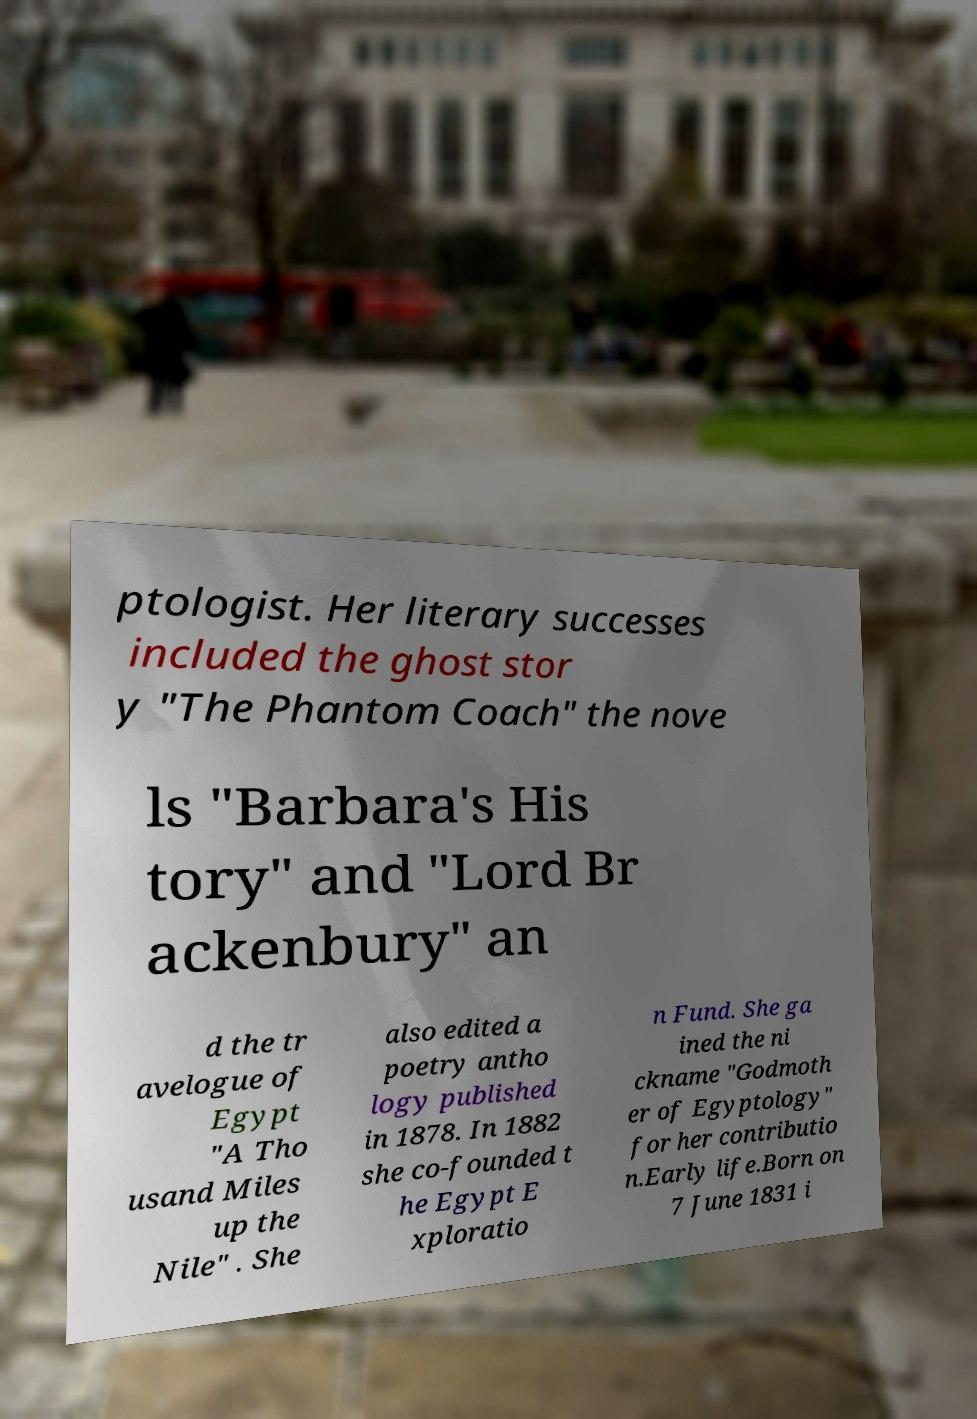Could you assist in decoding the text presented in this image and type it out clearly? ptologist. Her literary successes included the ghost stor y "The Phantom Coach" the nove ls "Barbara's His tory" and "Lord Br ackenbury" an d the tr avelogue of Egypt "A Tho usand Miles up the Nile" . She also edited a poetry antho logy published in 1878. In 1882 she co-founded t he Egypt E xploratio n Fund. She ga ined the ni ckname "Godmoth er of Egyptology" for her contributio n.Early life.Born on 7 June 1831 i 